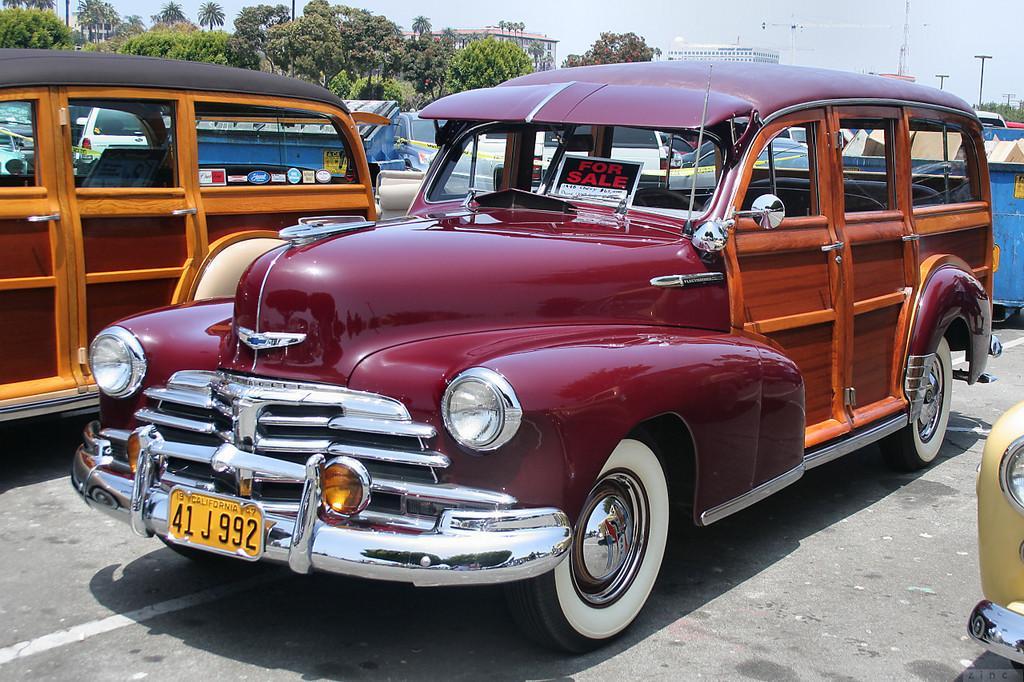How would you summarize this image in a sentence or two? In the middle of this image, there is a red color vehicle on the road. On both sides of this vehicle, there is a vehicle. In the background, there are other vehicles, trees, buildings and poles on the ground and there are clouds in the sky. 